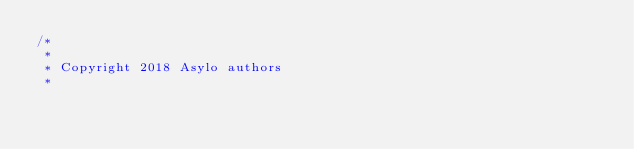Convert code to text. <code><loc_0><loc_0><loc_500><loc_500><_C++_>/*
 *
 * Copyright 2018 Asylo authors
 *</code> 